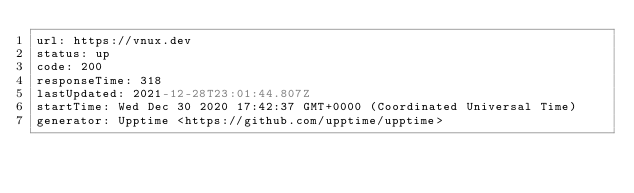Convert code to text. <code><loc_0><loc_0><loc_500><loc_500><_YAML_>url: https://vnux.dev
status: up
code: 200
responseTime: 318
lastUpdated: 2021-12-28T23:01:44.807Z
startTime: Wed Dec 30 2020 17:42:37 GMT+0000 (Coordinated Universal Time)
generator: Upptime <https://github.com/upptime/upptime>
</code> 